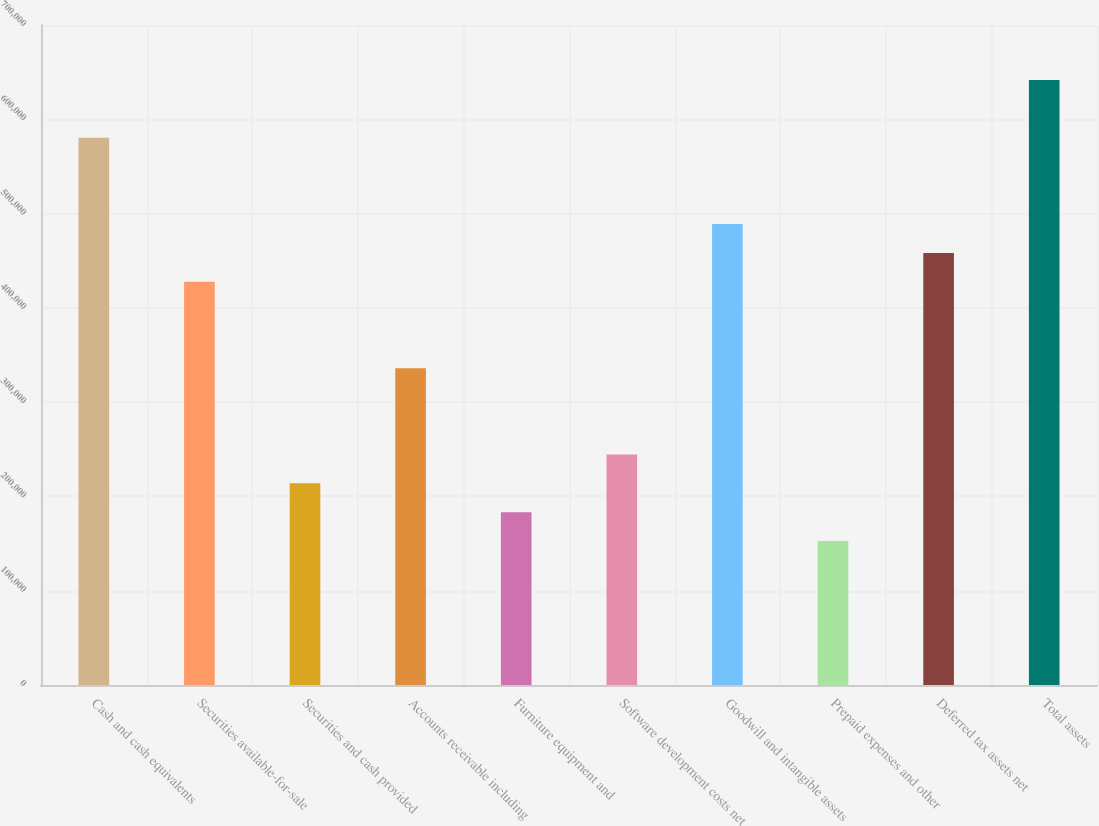<chart> <loc_0><loc_0><loc_500><loc_500><bar_chart><fcel>Cash and cash equivalents<fcel>Securities available-for-sale<fcel>Securities and cash provided<fcel>Accounts receivable including<fcel>Furniture equipment and<fcel>Software development costs net<fcel>Goodwill and intangible assets<fcel>Prepaid expenses and other<fcel>Deferred tax assets net<fcel>Total assets<nl><fcel>580457<fcel>427708<fcel>213858<fcel>336058<fcel>183308<fcel>244408<fcel>488807<fcel>152758<fcel>458258<fcel>641557<nl></chart> 